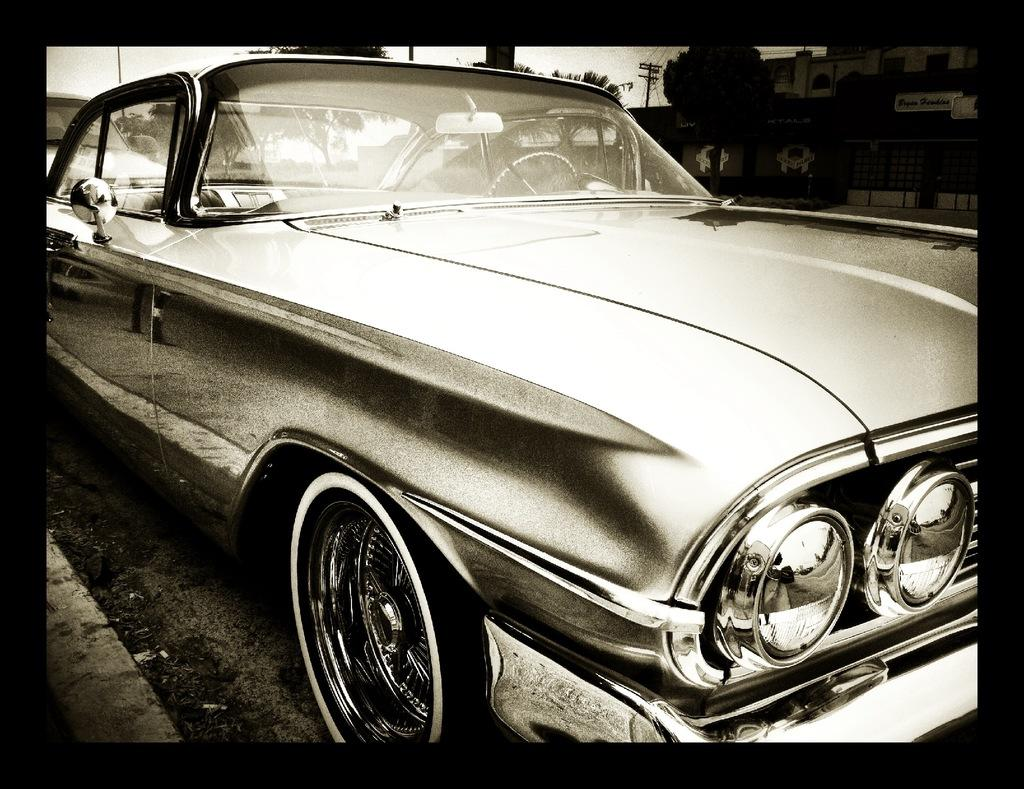What is the color scheme of the image? The image is black and white. What can be seen in the image? There is a car in the image. Where is the mountain located in the image? There is no mountain present in the image; it only features a car in a black and white setting. 